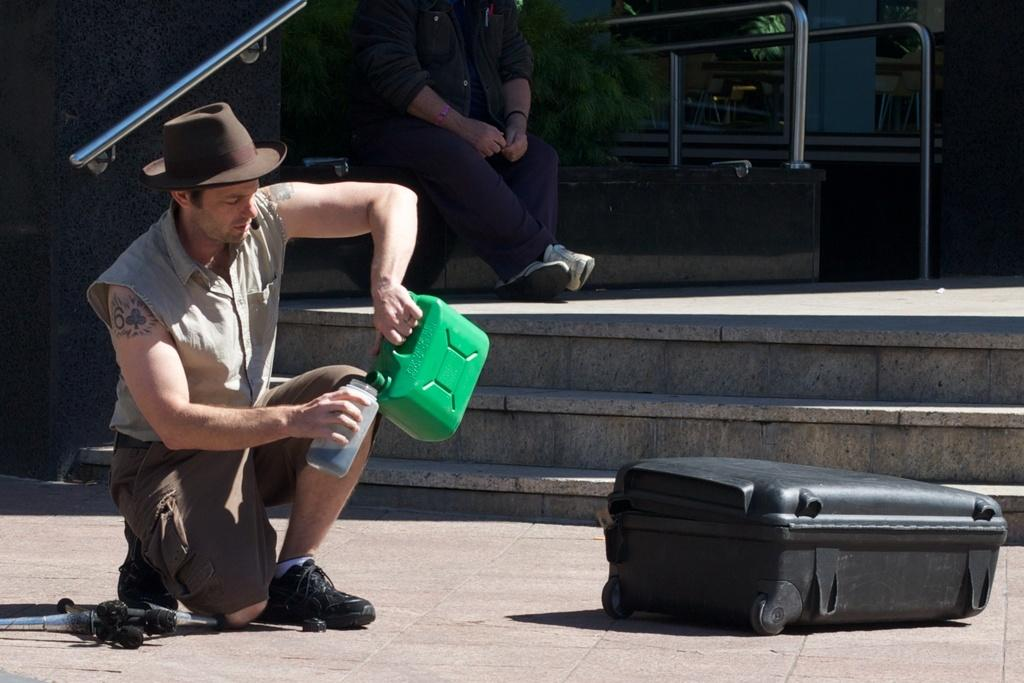What is the position of the man in the image? The man is kneeling in the image. What is the man holding in his hand? The man is holding a tin in his hand. Can you describe the other person in the image? There is a person seated in the image. How many ears can be seen on the man in the image? The image does not show the man's ears, so it is not possible to determine the number of ears. 